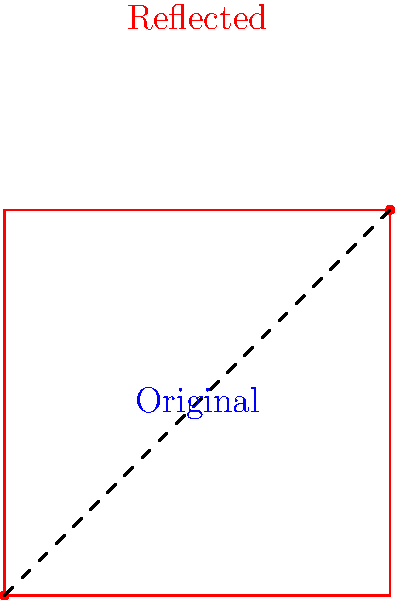In the diagram above, a musical motif is represented as a square geometric shape. The blue square represents the original motif, and the red square represents a transformed version. What type of transformation has been applied to the original motif, and how does this relate to symmetry in musical composition? To determine the transformation applied to the original motif, we need to analyze the relationship between the blue and red squares:

1. The blue square (original motif) is below the dashed line.
2. The red square (transformed motif) is above the dashed line.
3. The dashed line passes through the points (0,0) and (1,1).
4. The blue and red squares are mirror images of each other across the dashed line.

These observations indicate that the transformation applied is a reflection across the line y = x (the dashed line).

In musical composition, this type of transformation relates to symmetry in the following ways:

1. Reflection in music is often called "inversion" or "mirror inversion."
2. When a melodic line is inverted, the intervals between notes are preserved, but their direction is reversed.
3. This technique creates symmetry in the musical structure, as the original motif and its inversion are mirror images of each other.
4. Composers like Bach and Schoenberg often used such transformations to create complex, symmetrical musical structures.

In the context of classical piano music, this transformation could represent:
a) A melody played in one hand being mirrored in the other hand.
b) A theme introduced in one key being later inverted in a different section of the piece.
c) A compositional technique to create variation while maintaining structural coherence.

This type of symmetry adds depth and complexity to musical compositions, allowing for intricate interplay between different parts of a piece.
Answer: Reflection (mirror inversion) 